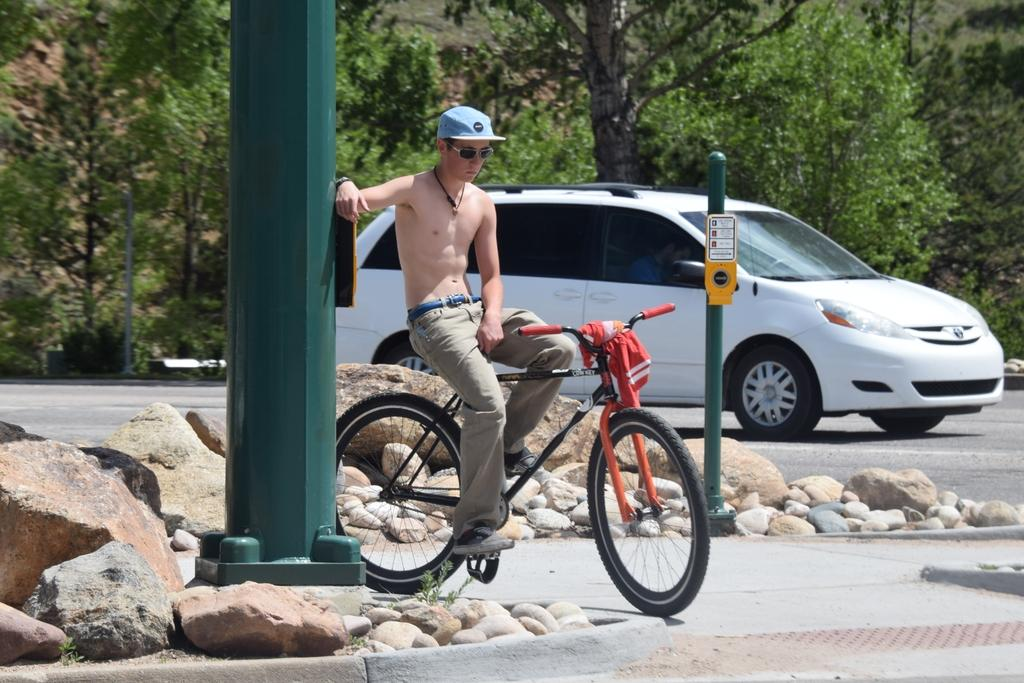What is the man doing in the image? The man is on a bicycle. What else is moving in the image? There is a car moving on the road. What type of plant can be seen in the image? There is a tree in the image. What can be found on the left side of the image? There are stones on the left side of the image. What is the rate of the cushion's movement in the image? There is no cushion present in the image, so it is not possible to determine its rate of movement. 